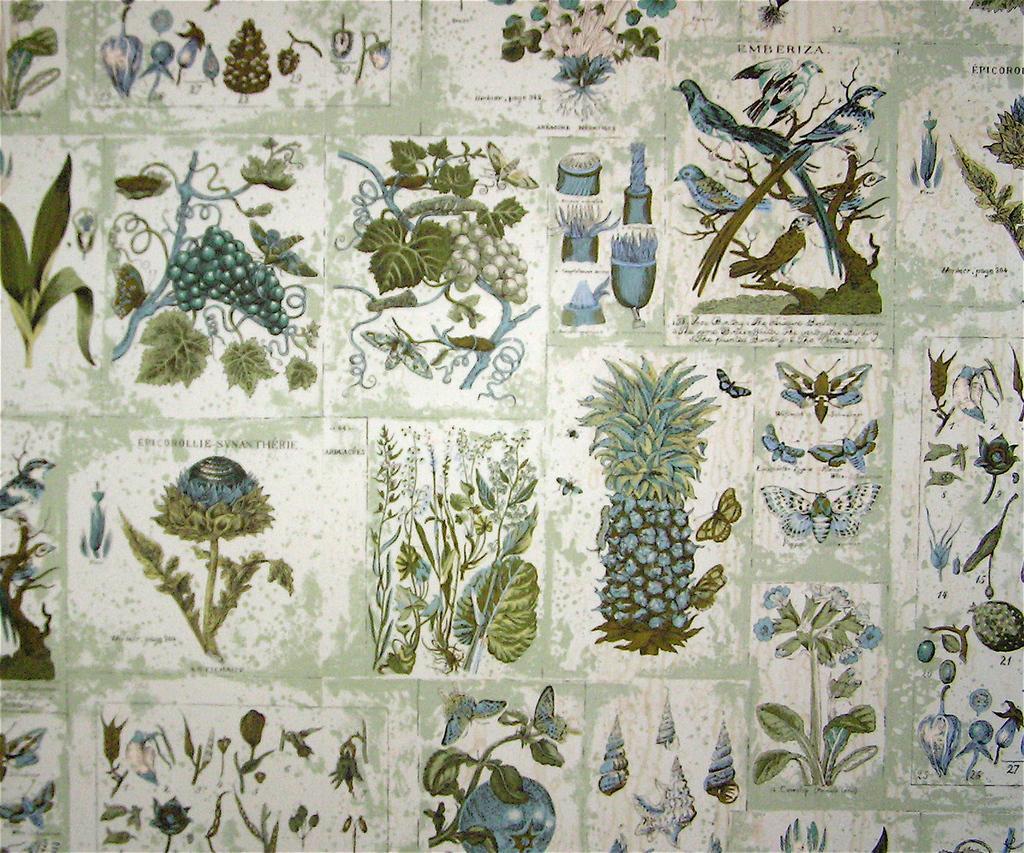Please provide a concise description of this image. In this image I can see number of posters in which I can see few plants which are green in color, a pineapple, few butterflies, few birds, few grapes and few flowers. 